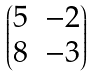Convert formula to latex. <formula><loc_0><loc_0><loc_500><loc_500>\begin{pmatrix} 5 & - 2 \\ 8 & - 3 \end{pmatrix}</formula> 